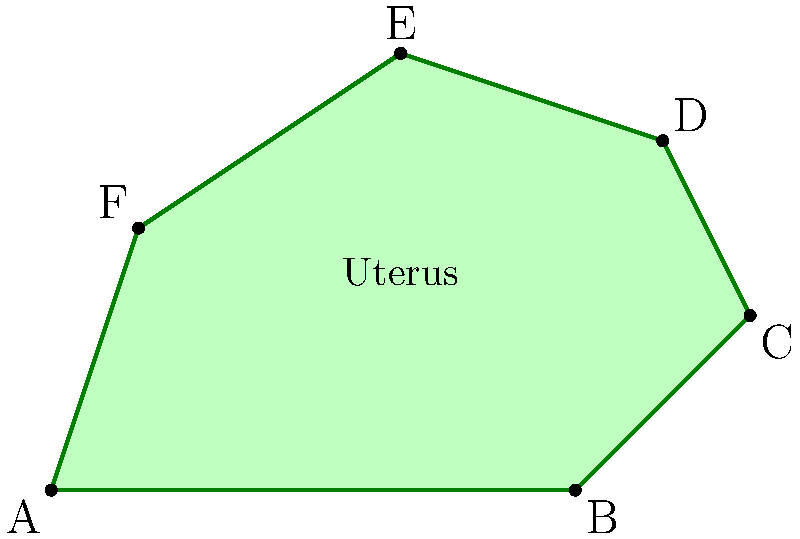The irregular polygon ABCDEF represents a cross-section of the uterus in the female reproductive system. Given that the length of AB is 6 cm and the height of the polygon at its tallest point is 5 cm, calculate the approximate area of the uterus cross-section using the trapezoidal rule with 3 equal divisions along the base. Round your answer to the nearest square centimeter. To solve this problem, we'll use the trapezoidal rule to approximate the area of the irregular polygon. Here's a step-by-step approach:

1) First, divide the base (AB) into 3 equal parts:
   $\Delta x = \frac{6 \text{ cm}}{3} = 2 \text{ cm}$

2) Find the y-coordinates (heights) at each division point:
   $x_0 = 0 \text{ cm}: y_0 = 0 \text{ cm}$
   $x_1 = 2 \text{ cm}: y_1 \approx 3 \text{ cm}$
   $x_2 = 4 \text{ cm}: y_2 \approx 4.5 \text{ cm}$
   $x_3 = 6 \text{ cm}: y_3 = 0 \text{ cm}$

3) Apply the trapezoidal rule formula:
   Area $\approx \frac{\Delta x}{2}[f(x_0) + 2f(x_1) + 2f(x_2) + f(x_3)]$
   
   Where $f(x_i)$ represents the height at each point.

4) Substitute the values:
   Area $\approx \frac{2}{2}[0 + 2(3) + 2(4.5) + 0]$
        $= 1[0 + 6 + 9 + 0]$
        $= 1[15]$
        $= 15 \text{ cm}^2$

5) Round to the nearest square centimeter:
   Area $\approx 15 \text{ cm}^2$
Answer: 15 cm² 